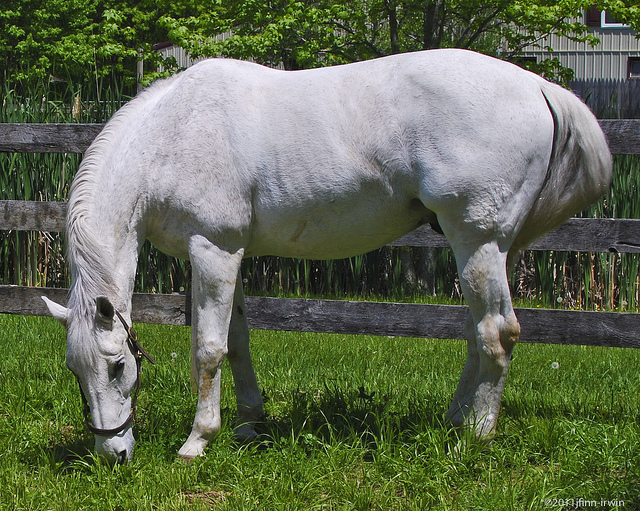How would you describe the posture of the horse? The posture of the horse is relaxed, with its head lowered to the ground as it grazes on the grass. This indicates that the horse is calm and comfortable in its environment. 